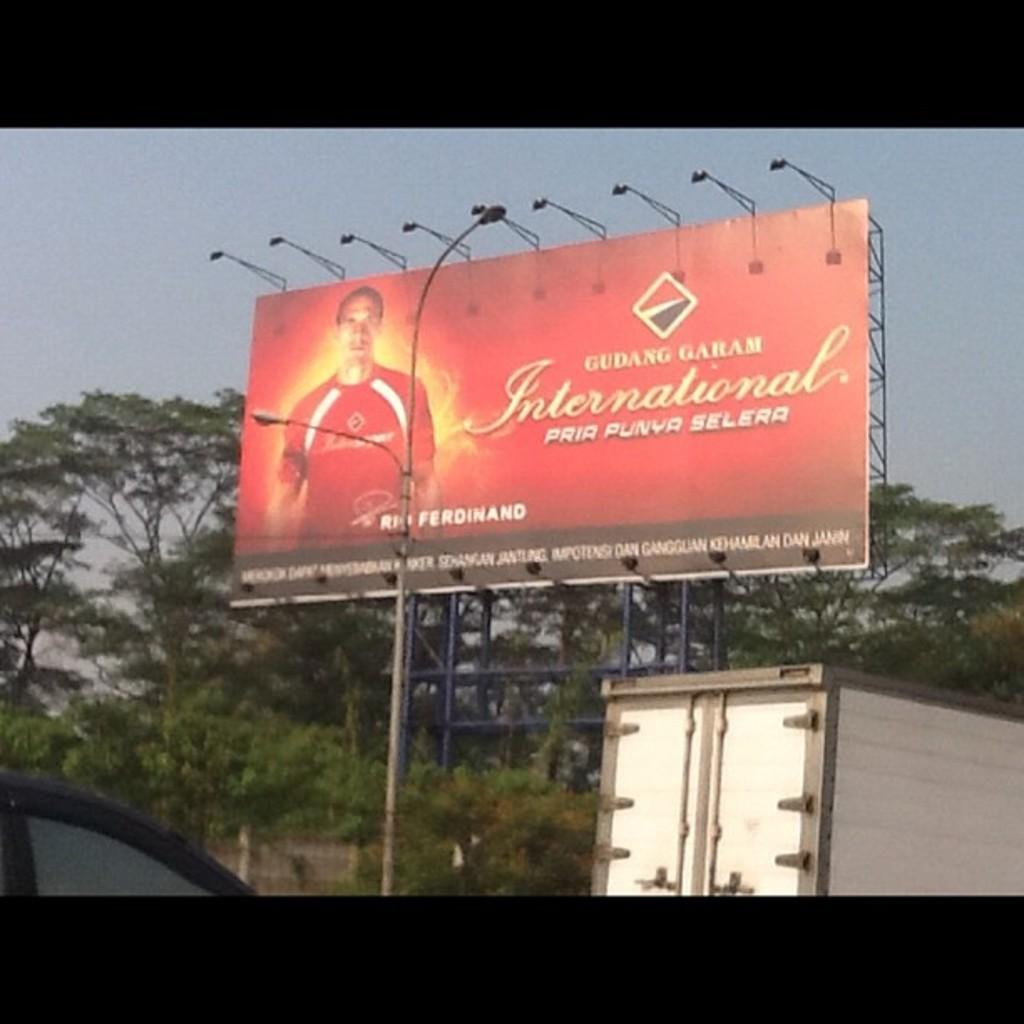<image>
Share a concise interpretation of the image provided. A large red billboard for Gudang Garam is surrounded by trees. 